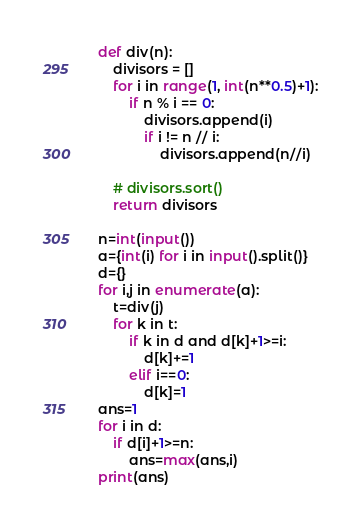Convert code to text. <code><loc_0><loc_0><loc_500><loc_500><_Python_>def div(n):
    divisors = []
    for i in range(1, int(n**0.5)+1):
        if n % i == 0:
            divisors.append(i)
            if i != n // i:
                divisors.append(n//i)

    # divisors.sort()
    return divisors

n=int(input())
a={int(i) for i in input().split()}
d={}
for i,j in enumerate(a):
    t=div(j)
    for k in t:
        if k in d and d[k]+1>=i:
            d[k]+=1
        elif i==0:
            d[k]=1
ans=1
for i in d:
    if d[i]+1>=n:
        ans=max(ans,i)
print(ans)
</code> 